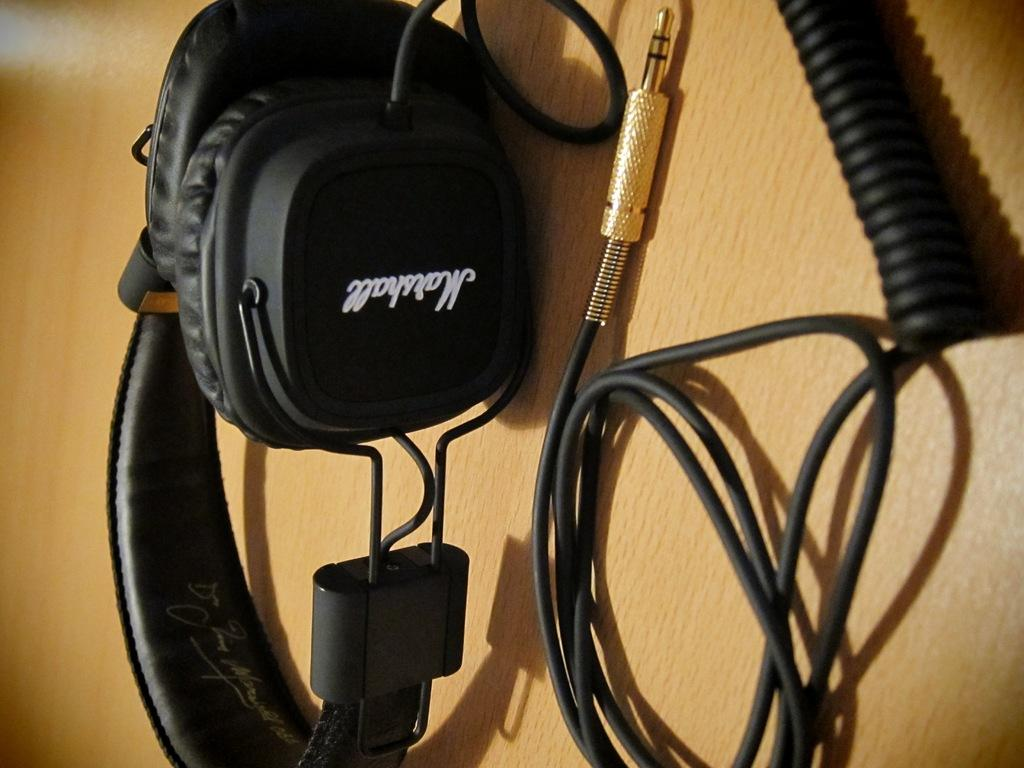What is the main object in the foreground of the image? There is a headset in the foreground of the image. What is the other object located near the headset? There is a plug in pin wire in the foreground of the image. What type of surface are the headset and wire placed on? Both the headset and the wire are on a wooden surface. What scent can be detected from the headset in the image? There is no mention of a scent in the image, and the headset does not emit a scent. How many brothers are visible in the image? There are no people, including brothers, present in the image. 